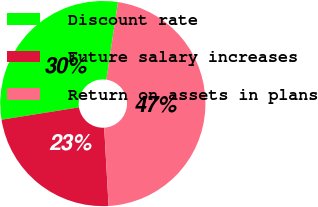<chart> <loc_0><loc_0><loc_500><loc_500><pie_chart><fcel>Discount rate<fcel>Future salary increases<fcel>Return on assets in plans<nl><fcel>29.87%<fcel>23.38%<fcel>46.75%<nl></chart> 